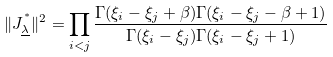<formula> <loc_0><loc_0><loc_500><loc_500>\| J ^ { ^ { * } } _ { \underline { \lambda } } \| ^ { 2 } = \prod _ { i < j } \frac { \Gamma ( \xi _ { i } - \xi _ { j } + \beta ) \Gamma ( \xi _ { i } - \xi _ { j } - \beta + 1 ) } { \Gamma ( \xi _ { i } - \xi _ { j } ) \Gamma ( \xi _ { i } - \xi _ { j } + 1 ) }</formula> 